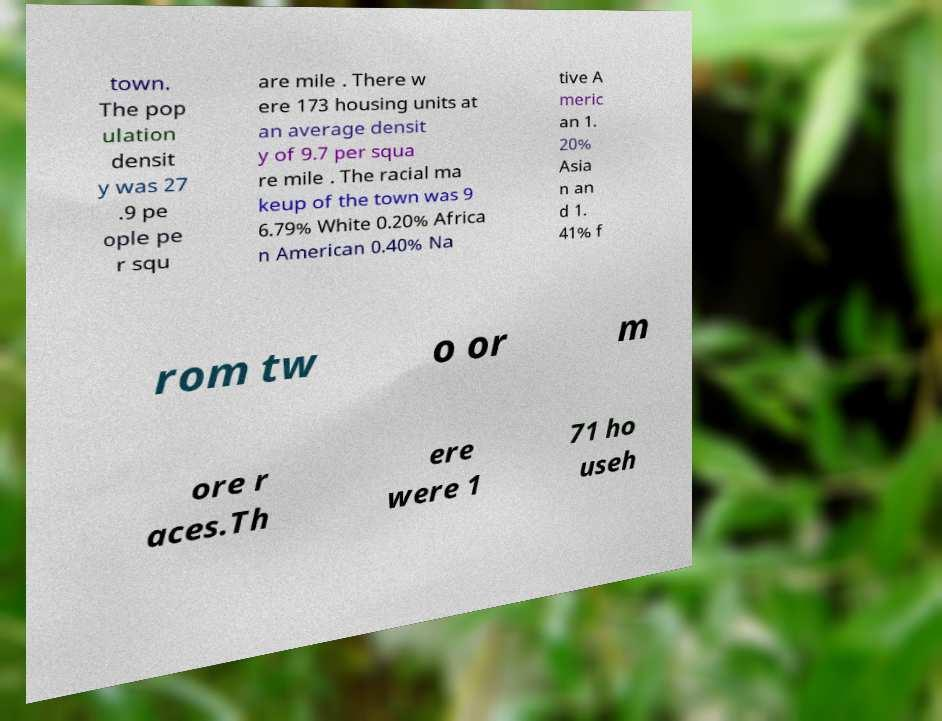There's text embedded in this image that I need extracted. Can you transcribe it verbatim? town. The pop ulation densit y was 27 .9 pe ople pe r squ are mile . There w ere 173 housing units at an average densit y of 9.7 per squa re mile . The racial ma keup of the town was 9 6.79% White 0.20% Africa n American 0.40% Na tive A meric an 1. 20% Asia n an d 1. 41% f rom tw o or m ore r aces.Th ere were 1 71 ho useh 